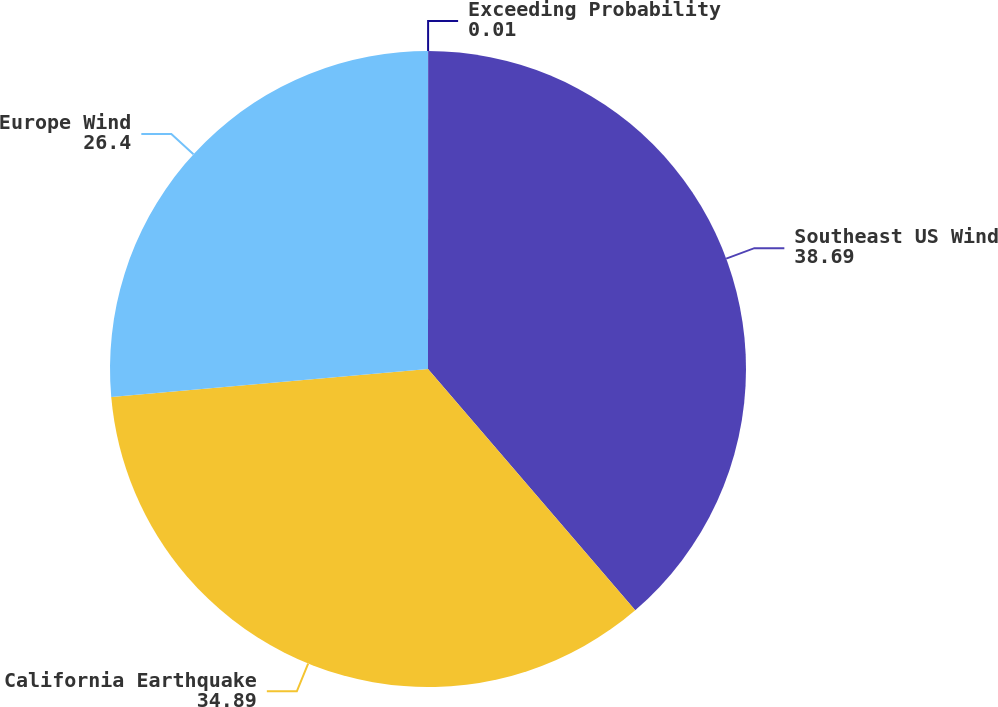Convert chart. <chart><loc_0><loc_0><loc_500><loc_500><pie_chart><fcel>Exceeding Probability<fcel>Southeast US Wind<fcel>California Earthquake<fcel>Europe Wind<nl><fcel>0.01%<fcel>38.69%<fcel>34.89%<fcel>26.4%<nl></chart> 